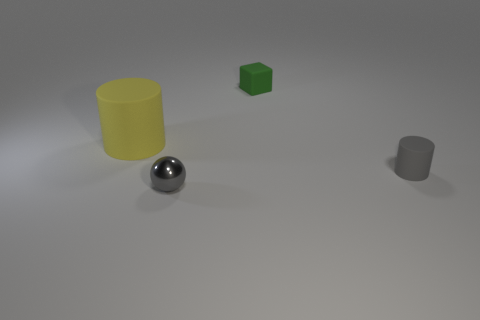Add 4 yellow rubber objects. How many objects exist? 8 Subtract all cubes. How many objects are left? 3 Subtract 0 green spheres. How many objects are left? 4 Subtract all large green rubber cylinders. Subtract all yellow objects. How many objects are left? 3 Add 4 metal balls. How many metal balls are left? 5 Add 2 tiny green matte things. How many tiny green matte things exist? 3 